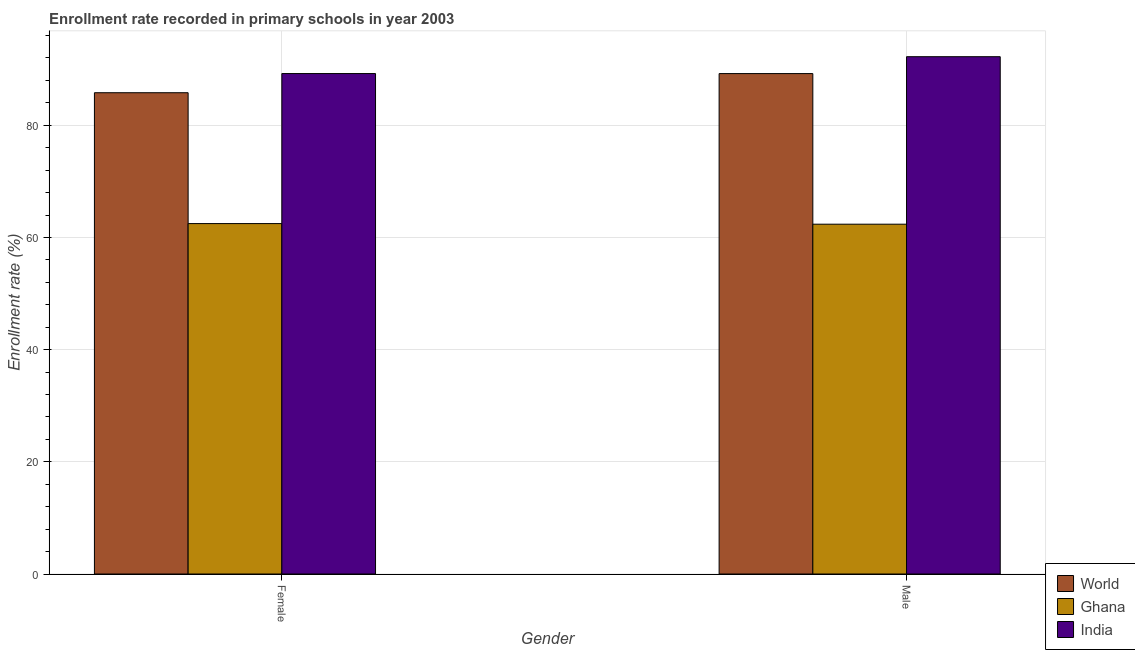How many different coloured bars are there?
Make the answer very short. 3. Are the number of bars per tick equal to the number of legend labels?
Offer a very short reply. Yes. Are the number of bars on each tick of the X-axis equal?
Your response must be concise. Yes. How many bars are there on the 2nd tick from the left?
Ensure brevity in your answer.  3. How many bars are there on the 2nd tick from the right?
Your answer should be very brief. 3. What is the label of the 1st group of bars from the left?
Ensure brevity in your answer.  Female. What is the enrollment rate of male students in World?
Offer a terse response. 89.22. Across all countries, what is the maximum enrollment rate of male students?
Your answer should be compact. 92.23. Across all countries, what is the minimum enrollment rate of male students?
Make the answer very short. 62.37. In which country was the enrollment rate of female students maximum?
Keep it short and to the point. India. In which country was the enrollment rate of female students minimum?
Your response must be concise. Ghana. What is the total enrollment rate of female students in the graph?
Make the answer very short. 237.5. What is the difference between the enrollment rate of female students in India and that in Ghana?
Ensure brevity in your answer.  26.75. What is the difference between the enrollment rate of female students in World and the enrollment rate of male students in Ghana?
Your answer should be compact. 23.44. What is the average enrollment rate of male students per country?
Ensure brevity in your answer.  81.27. What is the difference between the enrollment rate of male students and enrollment rate of female students in World?
Your answer should be very brief. 3.41. What is the ratio of the enrollment rate of female students in India to that in Ghana?
Your answer should be compact. 1.43. Is the enrollment rate of female students in Ghana less than that in India?
Your response must be concise. Yes. What does the 3rd bar from the right in Male represents?
Ensure brevity in your answer.  World. How many bars are there?
Give a very brief answer. 6. Does the graph contain any zero values?
Your response must be concise. No. Does the graph contain grids?
Keep it short and to the point. Yes. Where does the legend appear in the graph?
Make the answer very short. Bottom right. What is the title of the graph?
Make the answer very short. Enrollment rate recorded in primary schools in year 2003. What is the label or title of the X-axis?
Provide a short and direct response. Gender. What is the label or title of the Y-axis?
Keep it short and to the point. Enrollment rate (%). What is the Enrollment rate (%) of World in Female?
Your answer should be very brief. 85.81. What is the Enrollment rate (%) in Ghana in Female?
Offer a very short reply. 62.47. What is the Enrollment rate (%) of India in Female?
Keep it short and to the point. 89.22. What is the Enrollment rate (%) of World in Male?
Make the answer very short. 89.22. What is the Enrollment rate (%) of Ghana in Male?
Make the answer very short. 62.37. What is the Enrollment rate (%) in India in Male?
Provide a succinct answer. 92.23. Across all Gender, what is the maximum Enrollment rate (%) in World?
Keep it short and to the point. 89.22. Across all Gender, what is the maximum Enrollment rate (%) in Ghana?
Keep it short and to the point. 62.47. Across all Gender, what is the maximum Enrollment rate (%) in India?
Give a very brief answer. 92.23. Across all Gender, what is the minimum Enrollment rate (%) of World?
Offer a very short reply. 85.81. Across all Gender, what is the minimum Enrollment rate (%) in Ghana?
Make the answer very short. 62.37. Across all Gender, what is the minimum Enrollment rate (%) in India?
Provide a succinct answer. 89.22. What is the total Enrollment rate (%) of World in the graph?
Offer a terse response. 175.02. What is the total Enrollment rate (%) in Ghana in the graph?
Make the answer very short. 124.84. What is the total Enrollment rate (%) of India in the graph?
Give a very brief answer. 181.45. What is the difference between the Enrollment rate (%) in World in Female and that in Male?
Provide a short and direct response. -3.41. What is the difference between the Enrollment rate (%) in Ghana in Female and that in Male?
Offer a very short reply. 0.11. What is the difference between the Enrollment rate (%) in India in Female and that in Male?
Make the answer very short. -3.01. What is the difference between the Enrollment rate (%) in World in Female and the Enrollment rate (%) in Ghana in Male?
Give a very brief answer. 23.44. What is the difference between the Enrollment rate (%) of World in Female and the Enrollment rate (%) of India in Male?
Offer a terse response. -6.42. What is the difference between the Enrollment rate (%) in Ghana in Female and the Enrollment rate (%) in India in Male?
Offer a very short reply. -29.76. What is the average Enrollment rate (%) in World per Gender?
Your response must be concise. 87.51. What is the average Enrollment rate (%) in Ghana per Gender?
Your answer should be compact. 62.42. What is the average Enrollment rate (%) in India per Gender?
Offer a terse response. 90.73. What is the difference between the Enrollment rate (%) in World and Enrollment rate (%) in Ghana in Female?
Ensure brevity in your answer.  23.33. What is the difference between the Enrollment rate (%) in World and Enrollment rate (%) in India in Female?
Keep it short and to the point. -3.42. What is the difference between the Enrollment rate (%) of Ghana and Enrollment rate (%) of India in Female?
Offer a very short reply. -26.75. What is the difference between the Enrollment rate (%) of World and Enrollment rate (%) of Ghana in Male?
Provide a succinct answer. 26.85. What is the difference between the Enrollment rate (%) in World and Enrollment rate (%) in India in Male?
Give a very brief answer. -3.01. What is the difference between the Enrollment rate (%) in Ghana and Enrollment rate (%) in India in Male?
Your answer should be compact. -29.86. What is the ratio of the Enrollment rate (%) of World in Female to that in Male?
Ensure brevity in your answer.  0.96. What is the ratio of the Enrollment rate (%) in India in Female to that in Male?
Give a very brief answer. 0.97. What is the difference between the highest and the second highest Enrollment rate (%) of World?
Your answer should be very brief. 3.41. What is the difference between the highest and the second highest Enrollment rate (%) in Ghana?
Ensure brevity in your answer.  0.11. What is the difference between the highest and the second highest Enrollment rate (%) of India?
Offer a terse response. 3.01. What is the difference between the highest and the lowest Enrollment rate (%) of World?
Keep it short and to the point. 3.41. What is the difference between the highest and the lowest Enrollment rate (%) in Ghana?
Your answer should be compact. 0.11. What is the difference between the highest and the lowest Enrollment rate (%) in India?
Ensure brevity in your answer.  3.01. 